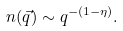<formula> <loc_0><loc_0><loc_500><loc_500>n ( \vec { q } ) \sim q ^ { - ( 1 - \eta ) } .</formula> 